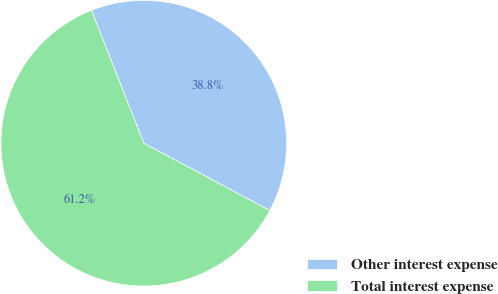Convert chart to OTSL. <chart><loc_0><loc_0><loc_500><loc_500><pie_chart><fcel>Other interest expense<fcel>Total interest expense<nl><fcel>38.78%<fcel>61.22%<nl></chart> 